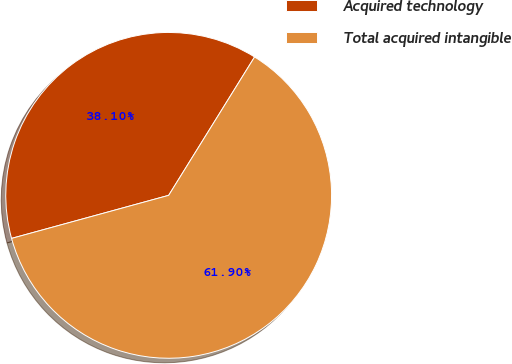Convert chart. <chart><loc_0><loc_0><loc_500><loc_500><pie_chart><fcel>Acquired technology<fcel>Total acquired intangible<nl><fcel>38.1%<fcel>61.9%<nl></chart> 